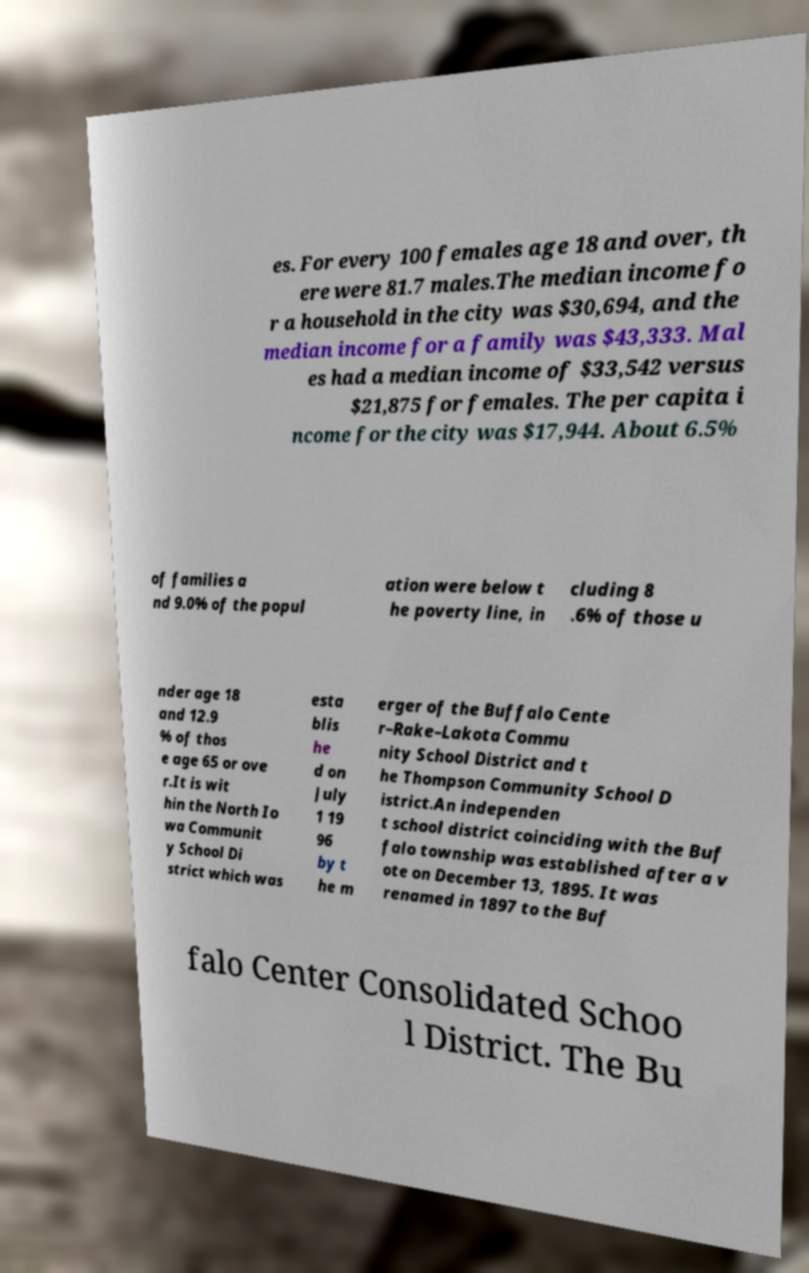For documentation purposes, I need the text within this image transcribed. Could you provide that? es. For every 100 females age 18 and over, th ere were 81.7 males.The median income fo r a household in the city was $30,694, and the median income for a family was $43,333. Mal es had a median income of $33,542 versus $21,875 for females. The per capita i ncome for the city was $17,944. About 6.5% of families a nd 9.0% of the popul ation were below t he poverty line, in cluding 8 .6% of those u nder age 18 and 12.9 % of thos e age 65 or ove r.It is wit hin the North Io wa Communit y School Di strict which was esta blis he d on July 1 19 96 by t he m erger of the Buffalo Cente r–Rake–Lakota Commu nity School District and t he Thompson Community School D istrict.An independen t school district coinciding with the Buf falo township was established after a v ote on December 13, 1895. It was renamed in 1897 to the Buf falo Center Consolidated Schoo l District. The Bu 